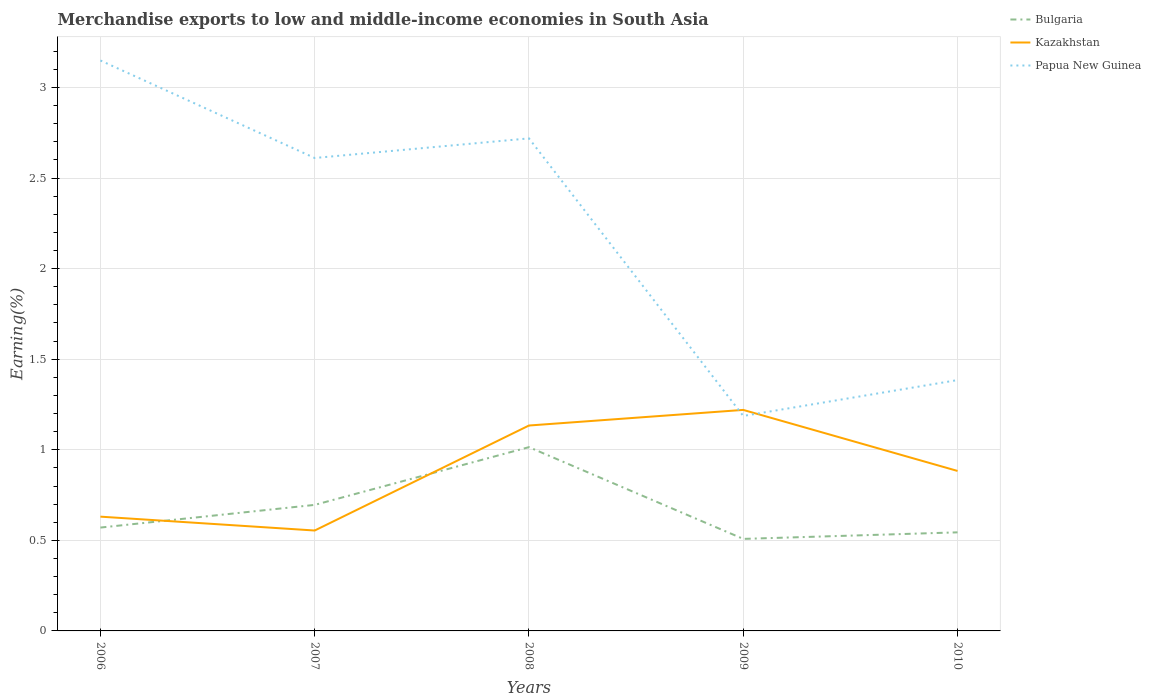Does the line corresponding to Bulgaria intersect with the line corresponding to Papua New Guinea?
Your response must be concise. No. Is the number of lines equal to the number of legend labels?
Ensure brevity in your answer.  Yes. Across all years, what is the maximum percentage of amount earned from merchandise exports in Papua New Guinea?
Make the answer very short. 1.19. What is the total percentage of amount earned from merchandise exports in Bulgaria in the graph?
Keep it short and to the point. -0.44. What is the difference between the highest and the second highest percentage of amount earned from merchandise exports in Kazakhstan?
Make the answer very short. 0.67. Is the percentage of amount earned from merchandise exports in Papua New Guinea strictly greater than the percentage of amount earned from merchandise exports in Kazakhstan over the years?
Your answer should be very brief. No. How many lines are there?
Offer a very short reply. 3. Does the graph contain any zero values?
Provide a short and direct response. No. How many legend labels are there?
Your answer should be very brief. 3. How are the legend labels stacked?
Give a very brief answer. Vertical. What is the title of the graph?
Make the answer very short. Merchandise exports to low and middle-income economies in South Asia. What is the label or title of the Y-axis?
Ensure brevity in your answer.  Earning(%). What is the Earning(%) in Bulgaria in 2006?
Your answer should be very brief. 0.57. What is the Earning(%) in Kazakhstan in 2006?
Keep it short and to the point. 0.63. What is the Earning(%) of Papua New Guinea in 2006?
Your answer should be very brief. 3.15. What is the Earning(%) of Bulgaria in 2007?
Ensure brevity in your answer.  0.7. What is the Earning(%) of Kazakhstan in 2007?
Make the answer very short. 0.55. What is the Earning(%) in Papua New Guinea in 2007?
Make the answer very short. 2.61. What is the Earning(%) of Bulgaria in 2008?
Provide a short and direct response. 1.01. What is the Earning(%) in Kazakhstan in 2008?
Ensure brevity in your answer.  1.13. What is the Earning(%) of Papua New Guinea in 2008?
Offer a very short reply. 2.72. What is the Earning(%) in Bulgaria in 2009?
Make the answer very short. 0.51. What is the Earning(%) of Kazakhstan in 2009?
Provide a succinct answer. 1.22. What is the Earning(%) of Papua New Guinea in 2009?
Your response must be concise. 1.19. What is the Earning(%) of Bulgaria in 2010?
Provide a short and direct response. 0.54. What is the Earning(%) of Kazakhstan in 2010?
Provide a short and direct response. 0.88. What is the Earning(%) in Papua New Guinea in 2010?
Make the answer very short. 1.38. Across all years, what is the maximum Earning(%) of Bulgaria?
Offer a terse response. 1.01. Across all years, what is the maximum Earning(%) of Kazakhstan?
Your answer should be compact. 1.22. Across all years, what is the maximum Earning(%) of Papua New Guinea?
Give a very brief answer. 3.15. Across all years, what is the minimum Earning(%) of Bulgaria?
Your response must be concise. 0.51. Across all years, what is the minimum Earning(%) of Kazakhstan?
Provide a succinct answer. 0.55. Across all years, what is the minimum Earning(%) of Papua New Guinea?
Your response must be concise. 1.19. What is the total Earning(%) in Bulgaria in the graph?
Ensure brevity in your answer.  3.33. What is the total Earning(%) of Kazakhstan in the graph?
Offer a very short reply. 4.42. What is the total Earning(%) of Papua New Guinea in the graph?
Your answer should be very brief. 11.05. What is the difference between the Earning(%) in Bulgaria in 2006 and that in 2007?
Keep it short and to the point. -0.13. What is the difference between the Earning(%) of Kazakhstan in 2006 and that in 2007?
Your answer should be compact. 0.08. What is the difference between the Earning(%) in Papua New Guinea in 2006 and that in 2007?
Make the answer very short. 0.54. What is the difference between the Earning(%) of Bulgaria in 2006 and that in 2008?
Make the answer very short. -0.44. What is the difference between the Earning(%) of Kazakhstan in 2006 and that in 2008?
Offer a very short reply. -0.5. What is the difference between the Earning(%) of Papua New Guinea in 2006 and that in 2008?
Ensure brevity in your answer.  0.43. What is the difference between the Earning(%) in Bulgaria in 2006 and that in 2009?
Offer a very short reply. 0.06. What is the difference between the Earning(%) in Kazakhstan in 2006 and that in 2009?
Offer a terse response. -0.59. What is the difference between the Earning(%) of Papua New Guinea in 2006 and that in 2009?
Give a very brief answer. 1.96. What is the difference between the Earning(%) of Bulgaria in 2006 and that in 2010?
Make the answer very short. 0.03. What is the difference between the Earning(%) in Kazakhstan in 2006 and that in 2010?
Give a very brief answer. -0.25. What is the difference between the Earning(%) of Papua New Guinea in 2006 and that in 2010?
Provide a succinct answer. 1.76. What is the difference between the Earning(%) in Bulgaria in 2007 and that in 2008?
Provide a succinct answer. -0.32. What is the difference between the Earning(%) in Kazakhstan in 2007 and that in 2008?
Offer a very short reply. -0.58. What is the difference between the Earning(%) of Papua New Guinea in 2007 and that in 2008?
Your answer should be compact. -0.11. What is the difference between the Earning(%) in Bulgaria in 2007 and that in 2009?
Ensure brevity in your answer.  0.19. What is the difference between the Earning(%) in Kazakhstan in 2007 and that in 2009?
Keep it short and to the point. -0.67. What is the difference between the Earning(%) of Papua New Guinea in 2007 and that in 2009?
Ensure brevity in your answer.  1.42. What is the difference between the Earning(%) of Bulgaria in 2007 and that in 2010?
Give a very brief answer. 0.15. What is the difference between the Earning(%) in Kazakhstan in 2007 and that in 2010?
Make the answer very short. -0.33. What is the difference between the Earning(%) of Papua New Guinea in 2007 and that in 2010?
Give a very brief answer. 1.23. What is the difference between the Earning(%) in Bulgaria in 2008 and that in 2009?
Make the answer very short. 0.51. What is the difference between the Earning(%) in Kazakhstan in 2008 and that in 2009?
Your response must be concise. -0.09. What is the difference between the Earning(%) in Papua New Guinea in 2008 and that in 2009?
Offer a very short reply. 1.53. What is the difference between the Earning(%) in Bulgaria in 2008 and that in 2010?
Offer a very short reply. 0.47. What is the difference between the Earning(%) of Kazakhstan in 2008 and that in 2010?
Your answer should be very brief. 0.25. What is the difference between the Earning(%) of Papua New Guinea in 2008 and that in 2010?
Your response must be concise. 1.33. What is the difference between the Earning(%) of Bulgaria in 2009 and that in 2010?
Provide a short and direct response. -0.04. What is the difference between the Earning(%) of Kazakhstan in 2009 and that in 2010?
Your answer should be very brief. 0.34. What is the difference between the Earning(%) in Papua New Guinea in 2009 and that in 2010?
Your answer should be compact. -0.2. What is the difference between the Earning(%) in Bulgaria in 2006 and the Earning(%) in Kazakhstan in 2007?
Your answer should be compact. 0.02. What is the difference between the Earning(%) in Bulgaria in 2006 and the Earning(%) in Papua New Guinea in 2007?
Offer a terse response. -2.04. What is the difference between the Earning(%) in Kazakhstan in 2006 and the Earning(%) in Papua New Guinea in 2007?
Your response must be concise. -1.98. What is the difference between the Earning(%) in Bulgaria in 2006 and the Earning(%) in Kazakhstan in 2008?
Offer a terse response. -0.56. What is the difference between the Earning(%) in Bulgaria in 2006 and the Earning(%) in Papua New Guinea in 2008?
Ensure brevity in your answer.  -2.15. What is the difference between the Earning(%) of Kazakhstan in 2006 and the Earning(%) of Papua New Guinea in 2008?
Make the answer very short. -2.09. What is the difference between the Earning(%) of Bulgaria in 2006 and the Earning(%) of Kazakhstan in 2009?
Your answer should be very brief. -0.65. What is the difference between the Earning(%) of Bulgaria in 2006 and the Earning(%) of Papua New Guinea in 2009?
Offer a terse response. -0.62. What is the difference between the Earning(%) of Kazakhstan in 2006 and the Earning(%) of Papua New Guinea in 2009?
Give a very brief answer. -0.56. What is the difference between the Earning(%) in Bulgaria in 2006 and the Earning(%) in Kazakhstan in 2010?
Provide a succinct answer. -0.31. What is the difference between the Earning(%) of Bulgaria in 2006 and the Earning(%) of Papua New Guinea in 2010?
Your response must be concise. -0.81. What is the difference between the Earning(%) of Kazakhstan in 2006 and the Earning(%) of Papua New Guinea in 2010?
Give a very brief answer. -0.75. What is the difference between the Earning(%) in Bulgaria in 2007 and the Earning(%) in Kazakhstan in 2008?
Offer a very short reply. -0.44. What is the difference between the Earning(%) of Bulgaria in 2007 and the Earning(%) of Papua New Guinea in 2008?
Provide a succinct answer. -2.02. What is the difference between the Earning(%) of Kazakhstan in 2007 and the Earning(%) of Papua New Guinea in 2008?
Make the answer very short. -2.16. What is the difference between the Earning(%) of Bulgaria in 2007 and the Earning(%) of Kazakhstan in 2009?
Provide a succinct answer. -0.52. What is the difference between the Earning(%) in Bulgaria in 2007 and the Earning(%) in Papua New Guinea in 2009?
Provide a succinct answer. -0.49. What is the difference between the Earning(%) in Kazakhstan in 2007 and the Earning(%) in Papua New Guinea in 2009?
Make the answer very short. -0.63. What is the difference between the Earning(%) of Bulgaria in 2007 and the Earning(%) of Kazakhstan in 2010?
Offer a terse response. -0.19. What is the difference between the Earning(%) of Bulgaria in 2007 and the Earning(%) of Papua New Guinea in 2010?
Offer a very short reply. -0.69. What is the difference between the Earning(%) of Kazakhstan in 2007 and the Earning(%) of Papua New Guinea in 2010?
Offer a very short reply. -0.83. What is the difference between the Earning(%) of Bulgaria in 2008 and the Earning(%) of Kazakhstan in 2009?
Your response must be concise. -0.21. What is the difference between the Earning(%) of Bulgaria in 2008 and the Earning(%) of Papua New Guinea in 2009?
Offer a very short reply. -0.17. What is the difference between the Earning(%) in Kazakhstan in 2008 and the Earning(%) in Papua New Guinea in 2009?
Make the answer very short. -0.05. What is the difference between the Earning(%) in Bulgaria in 2008 and the Earning(%) in Kazakhstan in 2010?
Make the answer very short. 0.13. What is the difference between the Earning(%) of Bulgaria in 2008 and the Earning(%) of Papua New Guinea in 2010?
Your response must be concise. -0.37. What is the difference between the Earning(%) of Kazakhstan in 2008 and the Earning(%) of Papua New Guinea in 2010?
Make the answer very short. -0.25. What is the difference between the Earning(%) of Bulgaria in 2009 and the Earning(%) of Kazakhstan in 2010?
Offer a terse response. -0.38. What is the difference between the Earning(%) of Bulgaria in 2009 and the Earning(%) of Papua New Guinea in 2010?
Your answer should be compact. -0.88. What is the difference between the Earning(%) of Kazakhstan in 2009 and the Earning(%) of Papua New Guinea in 2010?
Give a very brief answer. -0.16. What is the average Earning(%) in Bulgaria per year?
Provide a succinct answer. 0.67. What is the average Earning(%) in Kazakhstan per year?
Keep it short and to the point. 0.88. What is the average Earning(%) of Papua New Guinea per year?
Your answer should be compact. 2.21. In the year 2006, what is the difference between the Earning(%) in Bulgaria and Earning(%) in Kazakhstan?
Provide a succinct answer. -0.06. In the year 2006, what is the difference between the Earning(%) of Bulgaria and Earning(%) of Papua New Guinea?
Keep it short and to the point. -2.58. In the year 2006, what is the difference between the Earning(%) in Kazakhstan and Earning(%) in Papua New Guinea?
Offer a very short reply. -2.52. In the year 2007, what is the difference between the Earning(%) of Bulgaria and Earning(%) of Kazakhstan?
Your response must be concise. 0.14. In the year 2007, what is the difference between the Earning(%) in Bulgaria and Earning(%) in Papua New Guinea?
Give a very brief answer. -1.92. In the year 2007, what is the difference between the Earning(%) of Kazakhstan and Earning(%) of Papua New Guinea?
Make the answer very short. -2.06. In the year 2008, what is the difference between the Earning(%) in Bulgaria and Earning(%) in Kazakhstan?
Your answer should be very brief. -0.12. In the year 2008, what is the difference between the Earning(%) of Bulgaria and Earning(%) of Papua New Guinea?
Provide a succinct answer. -1.7. In the year 2008, what is the difference between the Earning(%) of Kazakhstan and Earning(%) of Papua New Guinea?
Make the answer very short. -1.59. In the year 2009, what is the difference between the Earning(%) of Bulgaria and Earning(%) of Kazakhstan?
Offer a terse response. -0.71. In the year 2009, what is the difference between the Earning(%) in Bulgaria and Earning(%) in Papua New Guinea?
Ensure brevity in your answer.  -0.68. In the year 2009, what is the difference between the Earning(%) in Kazakhstan and Earning(%) in Papua New Guinea?
Provide a succinct answer. 0.03. In the year 2010, what is the difference between the Earning(%) in Bulgaria and Earning(%) in Kazakhstan?
Your answer should be very brief. -0.34. In the year 2010, what is the difference between the Earning(%) of Bulgaria and Earning(%) of Papua New Guinea?
Provide a succinct answer. -0.84. In the year 2010, what is the difference between the Earning(%) of Kazakhstan and Earning(%) of Papua New Guinea?
Provide a short and direct response. -0.5. What is the ratio of the Earning(%) in Bulgaria in 2006 to that in 2007?
Provide a short and direct response. 0.82. What is the ratio of the Earning(%) in Kazakhstan in 2006 to that in 2007?
Offer a terse response. 1.14. What is the ratio of the Earning(%) in Papua New Guinea in 2006 to that in 2007?
Give a very brief answer. 1.21. What is the ratio of the Earning(%) of Bulgaria in 2006 to that in 2008?
Offer a very short reply. 0.56. What is the ratio of the Earning(%) of Kazakhstan in 2006 to that in 2008?
Give a very brief answer. 0.56. What is the ratio of the Earning(%) in Papua New Guinea in 2006 to that in 2008?
Provide a short and direct response. 1.16. What is the ratio of the Earning(%) of Bulgaria in 2006 to that in 2009?
Your response must be concise. 1.12. What is the ratio of the Earning(%) of Kazakhstan in 2006 to that in 2009?
Keep it short and to the point. 0.52. What is the ratio of the Earning(%) in Papua New Guinea in 2006 to that in 2009?
Ensure brevity in your answer.  2.65. What is the ratio of the Earning(%) of Bulgaria in 2006 to that in 2010?
Ensure brevity in your answer.  1.05. What is the ratio of the Earning(%) of Kazakhstan in 2006 to that in 2010?
Make the answer very short. 0.71. What is the ratio of the Earning(%) in Papua New Guinea in 2006 to that in 2010?
Offer a very short reply. 2.27. What is the ratio of the Earning(%) of Bulgaria in 2007 to that in 2008?
Your response must be concise. 0.69. What is the ratio of the Earning(%) in Kazakhstan in 2007 to that in 2008?
Your answer should be compact. 0.49. What is the ratio of the Earning(%) in Papua New Guinea in 2007 to that in 2008?
Your answer should be compact. 0.96. What is the ratio of the Earning(%) of Bulgaria in 2007 to that in 2009?
Provide a succinct answer. 1.37. What is the ratio of the Earning(%) in Kazakhstan in 2007 to that in 2009?
Your answer should be very brief. 0.45. What is the ratio of the Earning(%) of Papua New Guinea in 2007 to that in 2009?
Your answer should be compact. 2.2. What is the ratio of the Earning(%) of Bulgaria in 2007 to that in 2010?
Your answer should be very brief. 1.28. What is the ratio of the Earning(%) of Kazakhstan in 2007 to that in 2010?
Offer a very short reply. 0.63. What is the ratio of the Earning(%) of Papua New Guinea in 2007 to that in 2010?
Give a very brief answer. 1.89. What is the ratio of the Earning(%) of Bulgaria in 2008 to that in 2009?
Your answer should be very brief. 2. What is the ratio of the Earning(%) in Kazakhstan in 2008 to that in 2009?
Give a very brief answer. 0.93. What is the ratio of the Earning(%) in Papua New Guinea in 2008 to that in 2009?
Keep it short and to the point. 2.29. What is the ratio of the Earning(%) of Bulgaria in 2008 to that in 2010?
Make the answer very short. 1.86. What is the ratio of the Earning(%) of Kazakhstan in 2008 to that in 2010?
Keep it short and to the point. 1.28. What is the ratio of the Earning(%) in Papua New Guinea in 2008 to that in 2010?
Keep it short and to the point. 1.96. What is the ratio of the Earning(%) of Bulgaria in 2009 to that in 2010?
Offer a very short reply. 0.93. What is the ratio of the Earning(%) in Kazakhstan in 2009 to that in 2010?
Provide a short and direct response. 1.38. What is the difference between the highest and the second highest Earning(%) in Bulgaria?
Give a very brief answer. 0.32. What is the difference between the highest and the second highest Earning(%) of Kazakhstan?
Give a very brief answer. 0.09. What is the difference between the highest and the second highest Earning(%) in Papua New Guinea?
Give a very brief answer. 0.43. What is the difference between the highest and the lowest Earning(%) in Bulgaria?
Your response must be concise. 0.51. What is the difference between the highest and the lowest Earning(%) in Kazakhstan?
Your answer should be very brief. 0.67. What is the difference between the highest and the lowest Earning(%) in Papua New Guinea?
Your answer should be very brief. 1.96. 